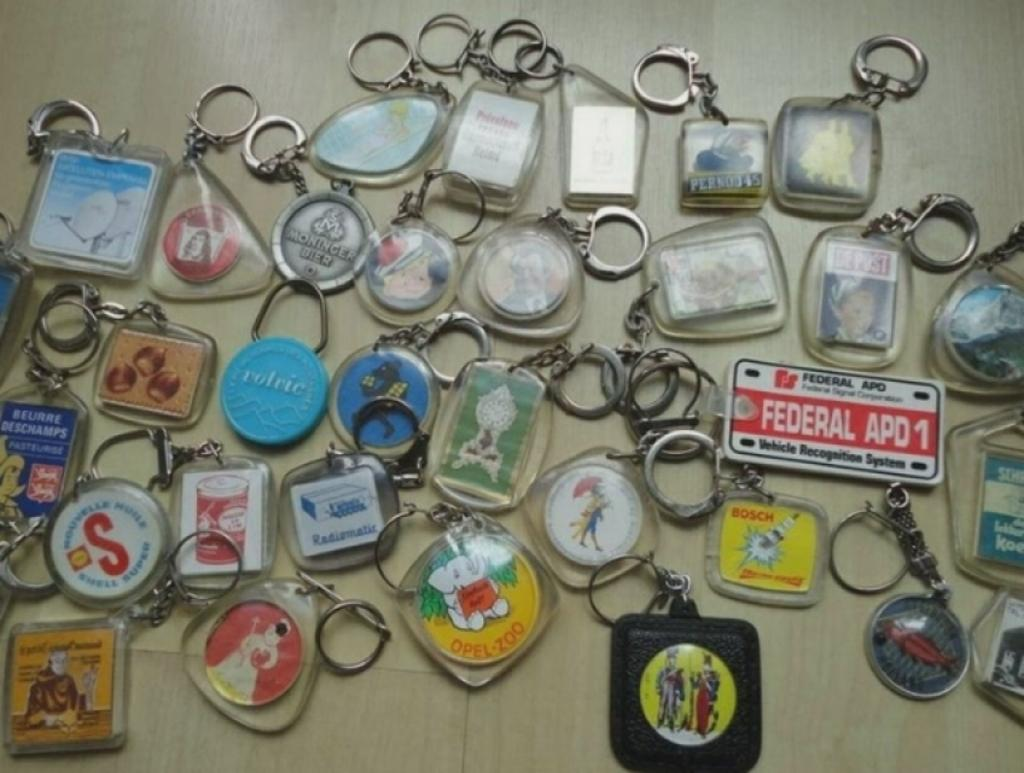What objects are present in the image? There are keychains in the image. Can you describe the shapes of the keychains? The keychains have different shapes, including square, rectangular, triangular, and circular. What is the color of the surface on which the keychains are placed? The surface on which the keychains are placed is cream-colored. Can you tell me if there is a crime scene near the lake in the image? There is no mention of a crime scene, lake, or camp in the image, so it cannot be determined if there is a crime scene near the lake. 